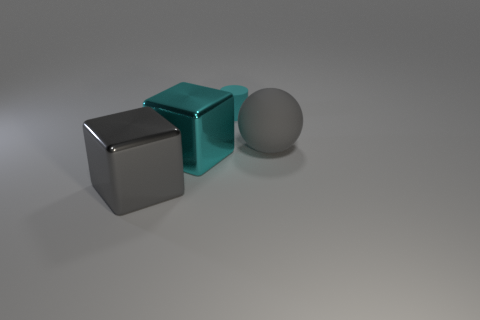There is a large metallic object that is the same color as the cylinder; what shape is it?
Your answer should be compact. Cube. There is a rubber object that is the same size as the gray metallic thing; what color is it?
Your answer should be compact. Gray. What number of objects are objects that are in front of the cyan matte cylinder or gray rubber balls?
Your answer should be compact. 3. What size is the thing that is both behind the cyan block and to the left of the gray sphere?
Keep it short and to the point. Small. What is the size of the metal thing that is the same color as the matte sphere?
Offer a terse response. Large. How many other objects are the same size as the cyan rubber thing?
Provide a short and direct response. 0. The block that is right of the big gray thing on the left side of the big gray thing right of the cyan metal cube is what color?
Keep it short and to the point. Cyan. There is a thing that is to the right of the large cyan block and on the left side of the big rubber ball; what is its shape?
Your answer should be compact. Cylinder. How many other things are the same shape as the gray rubber thing?
Provide a short and direct response. 0. What is the shape of the object that is behind the big object right of the metallic thing on the right side of the big gray metallic cube?
Make the answer very short. Cylinder. 